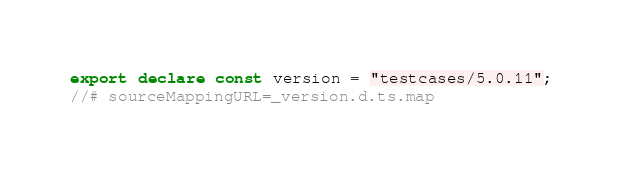Convert code to text. <code><loc_0><loc_0><loc_500><loc_500><_TypeScript_>export declare const version = "testcases/5.0.11";
//# sourceMappingURL=_version.d.ts.map</code> 